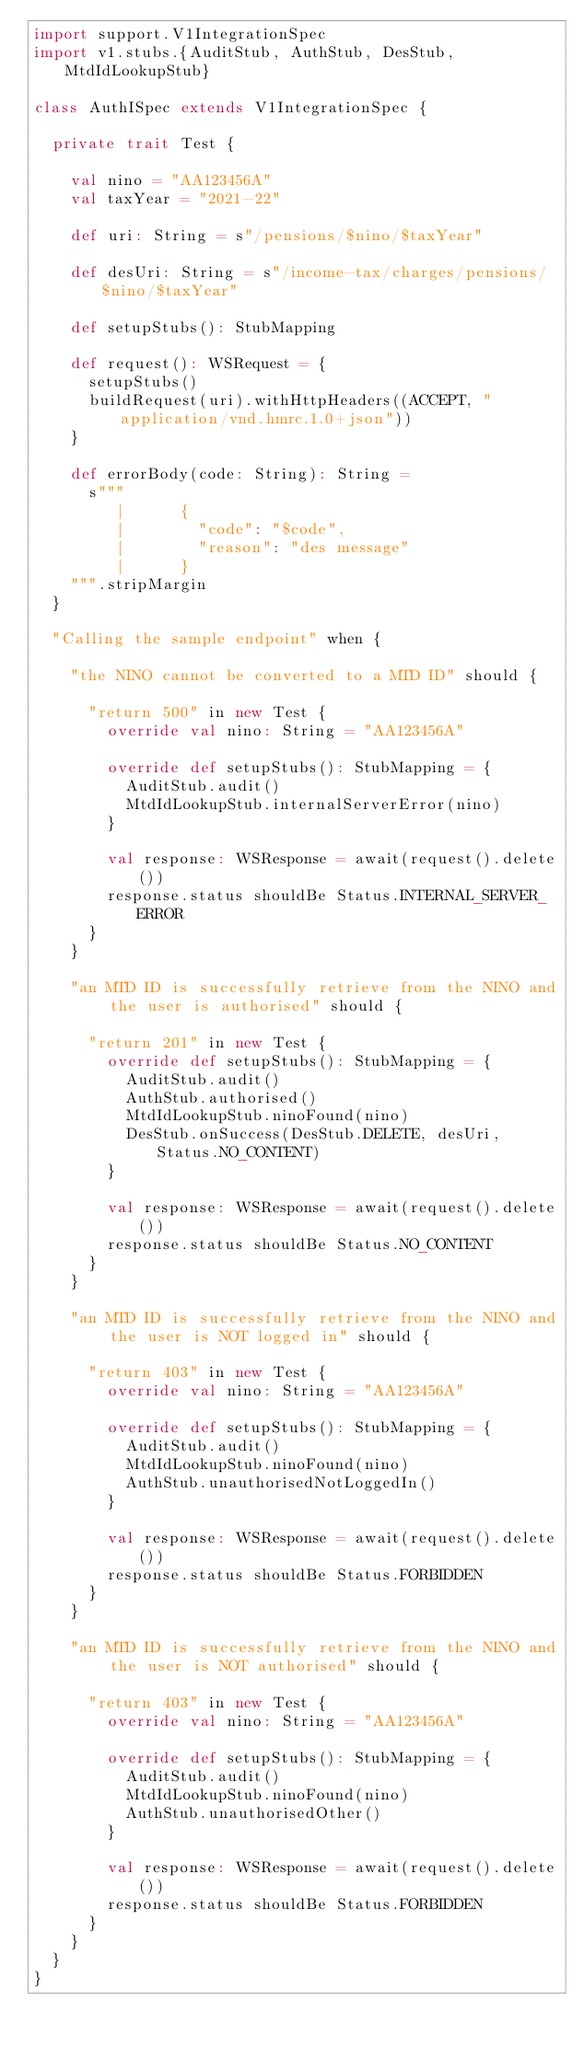<code> <loc_0><loc_0><loc_500><loc_500><_Scala_>import support.V1IntegrationSpec
import v1.stubs.{AuditStub, AuthStub, DesStub, MtdIdLookupStub}

class AuthISpec extends V1IntegrationSpec {

  private trait Test {

    val nino = "AA123456A"
    val taxYear = "2021-22"

    def uri: String = s"/pensions/$nino/$taxYear"

    def desUri: String = s"/income-tax/charges/pensions/$nino/$taxYear"

    def setupStubs(): StubMapping

    def request(): WSRequest = {
      setupStubs()
      buildRequest(uri).withHttpHeaders((ACCEPT, "application/vnd.hmrc.1.0+json"))
    }

    def errorBody(code: String): String =
      s"""
         |      {
         |        "code": "$code",
         |        "reason": "des message"
         |      }
    """.stripMargin
  }

  "Calling the sample endpoint" when {

    "the NINO cannot be converted to a MTD ID" should {

      "return 500" in new Test {
        override val nino: String = "AA123456A"

        override def setupStubs(): StubMapping = {
          AuditStub.audit()
          MtdIdLookupStub.internalServerError(nino)
        }

        val response: WSResponse = await(request().delete())
        response.status shouldBe Status.INTERNAL_SERVER_ERROR
      }
    }

    "an MTD ID is successfully retrieve from the NINO and the user is authorised" should {

      "return 201" in new Test {
        override def setupStubs(): StubMapping = {
          AuditStub.audit()
          AuthStub.authorised()
          MtdIdLookupStub.ninoFound(nino)
          DesStub.onSuccess(DesStub.DELETE, desUri, Status.NO_CONTENT)
        }

        val response: WSResponse = await(request().delete())
        response.status shouldBe Status.NO_CONTENT
      }
    }

    "an MTD ID is successfully retrieve from the NINO and the user is NOT logged in" should {

      "return 403" in new Test {
        override val nino: String = "AA123456A"

        override def setupStubs(): StubMapping = {
          AuditStub.audit()
          MtdIdLookupStub.ninoFound(nino)
          AuthStub.unauthorisedNotLoggedIn()
        }

        val response: WSResponse = await(request().delete())
        response.status shouldBe Status.FORBIDDEN
      }
    }

    "an MTD ID is successfully retrieve from the NINO and the user is NOT authorised" should {

      "return 403" in new Test {
        override val nino: String = "AA123456A"

        override def setupStubs(): StubMapping = {
          AuditStub.audit()
          MtdIdLookupStub.ninoFound(nino)
          AuthStub.unauthorisedOther()
        }

        val response: WSResponse = await(request().delete())
        response.status shouldBe Status.FORBIDDEN
      }
    }
  }
}
</code> 